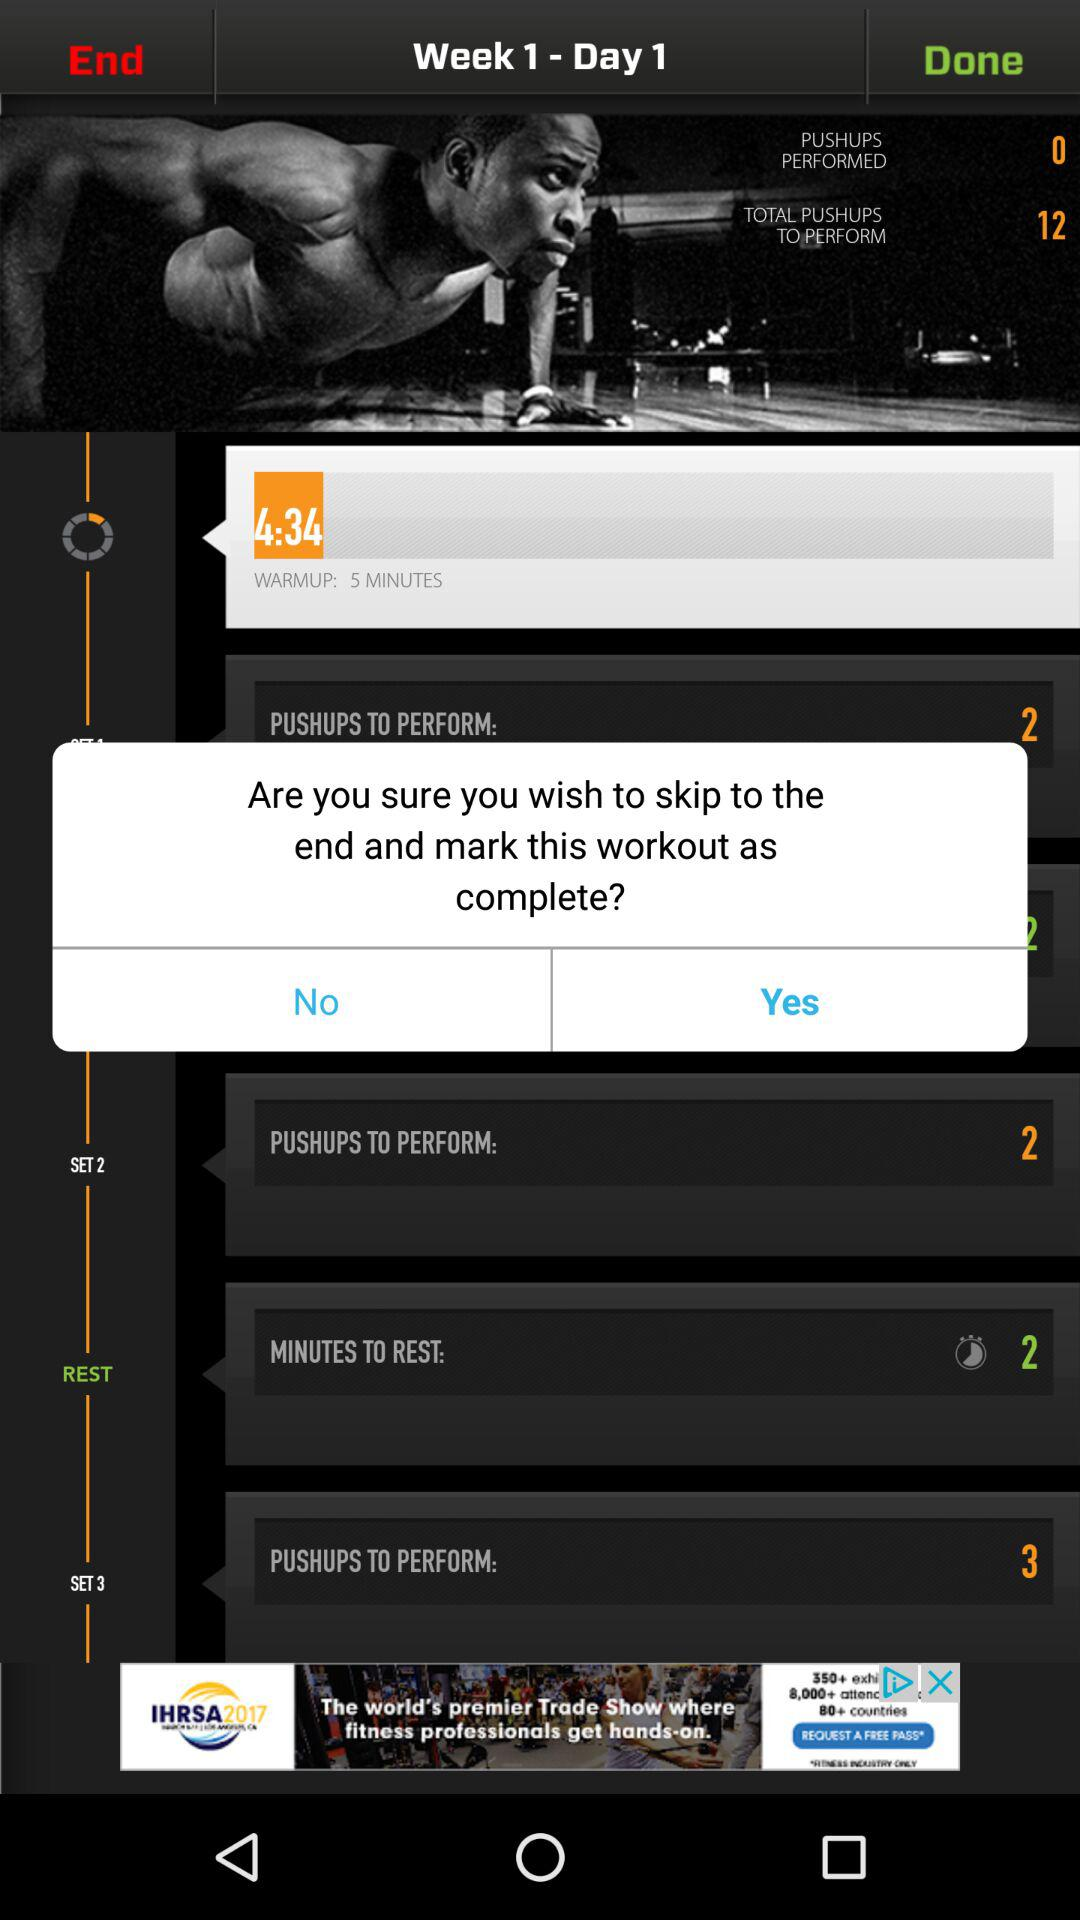What is the time duration for the rest? The time duration for the rest is 2 minutes. 